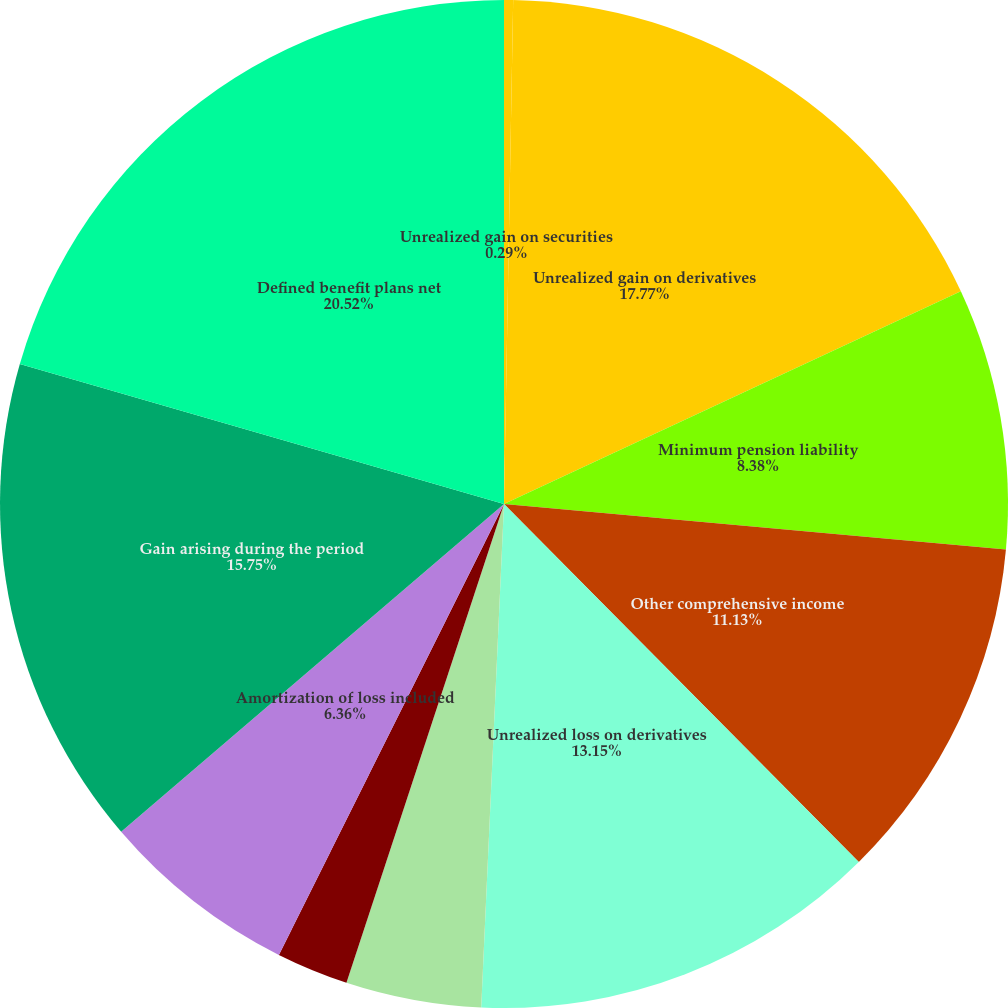Convert chart. <chart><loc_0><loc_0><loc_500><loc_500><pie_chart><fcel>Unrealized gain on securities<fcel>Unrealized gain on derivatives<fcel>Minimum pension liability<fcel>Other comprehensive income<fcel>Unrealized loss on derivatives<fcel>Amortization of transition<fcel>Amortization of prior service<fcel>Amortization of loss included<fcel>Gain arising during the period<fcel>Defined benefit plans net<nl><fcel>0.29%<fcel>17.77%<fcel>8.38%<fcel>11.13%<fcel>13.15%<fcel>4.34%<fcel>2.31%<fcel>6.36%<fcel>15.75%<fcel>20.52%<nl></chart> 